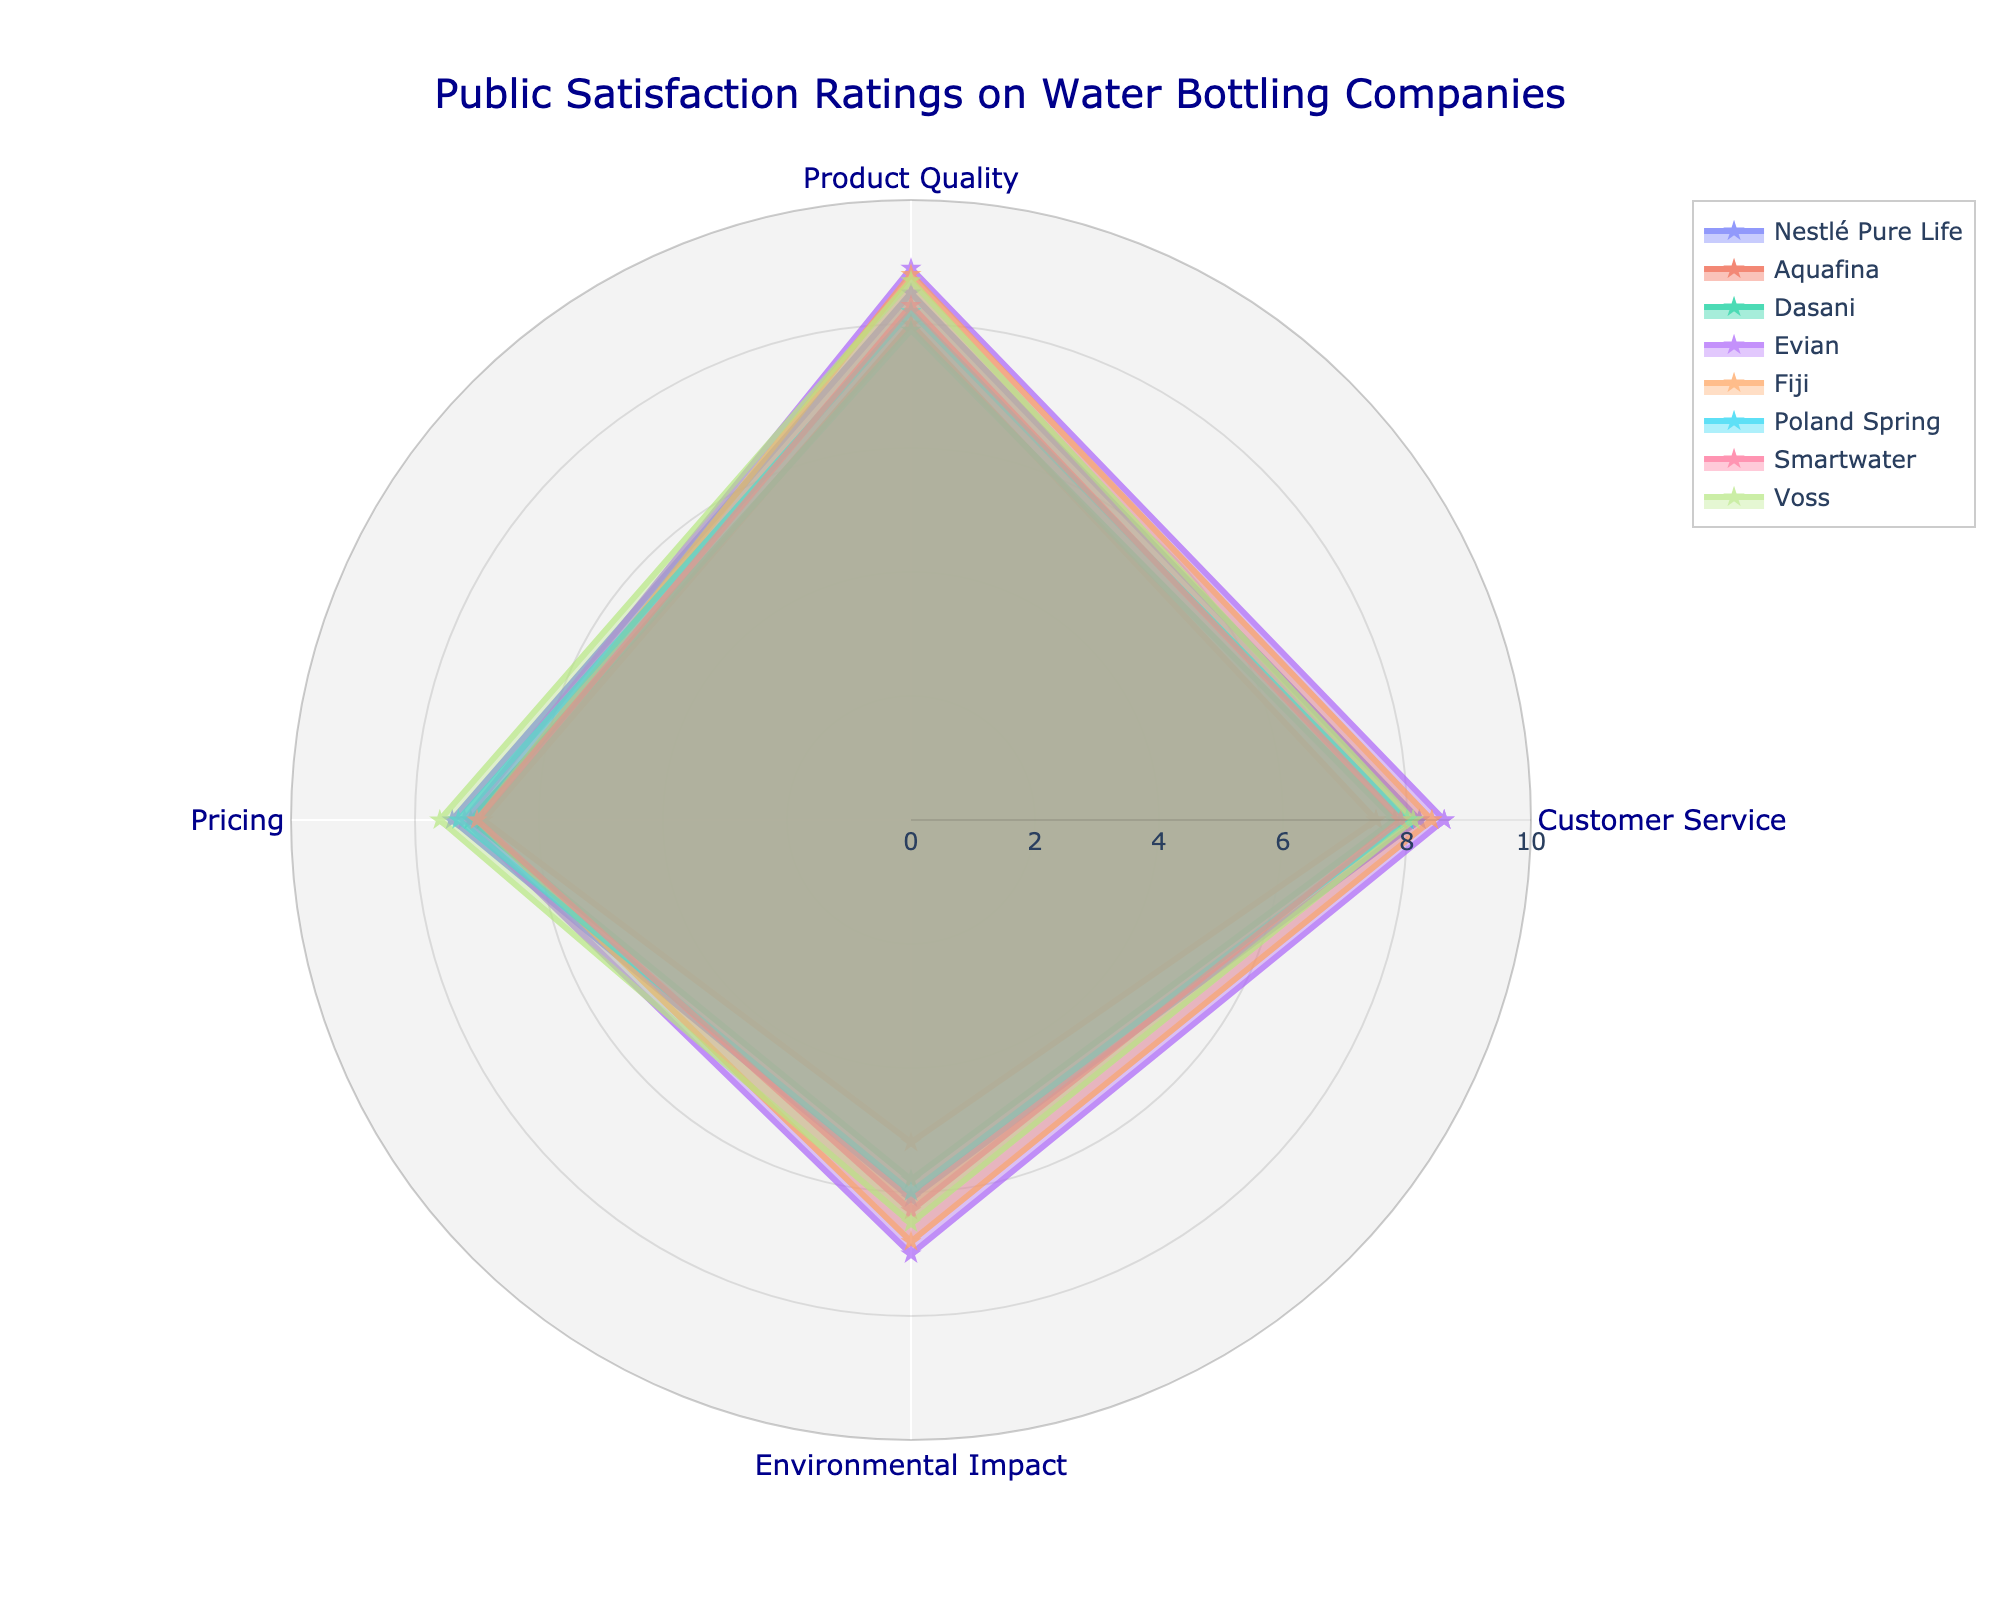How many categories are evaluated for each water company? The radar chart has four axes, each representing a different category. The categories are Customer Service, Product Quality, Pricing, and Environmental Impact. By counting these axes, we see that there are four categories.
Answer: Four Which company has the highest rating for Product Quality? Looking at the radar chart, the company with the highest point on the 'Product Quality' axis is Evian, which scores 8.9 in this category.
Answer: Evian Between Aquafina and Fiji, which company is rated higher in Environmental Impact? On the 'Environmental Impact' axis, Fiji is closer to the outer edge than Aquafina. Aquafina has a rating of 5.2, while Fiji is rated 6.8.
Answer: Fiji What is the average Product Quality rating across all companies? Sum the Product Quality ratings for all companies: (8.5 + 8.0 + 7.9 + 8.9 + 8.8 + 8.2 + 8.3 + 8.7). The total is 67.3. Divide by the number of companies, which is 8. Thus, the average is 67.3 / 8 = 8.41.
Answer: 8.41 Which company has the most balanced ratings across all categories? To identify the most balanced company, look for the shape that is closest to a complete polygon without significant peaks or troughs. Voss has a fairly balanced shape with moderately high but not extreme values in each category.
Answer: Voss What is the difference in Customer Service ratings between the highest and lowest-rated companies? The highest rating for Customer Service is 8.6 by Evian, while the lowest is 7.5 by Aquafina. The difference is 8.6 - 7.5 = 1.1.
Answer: 1.1 Which company has the lowest overall satisfaction in Pricing? The company closest to the center on the 'Pricing' axis is Aquafina, which scores 6.9 in this category.
Answer: Aquafina Do any two companies have the same rating in any category? By inspecting the radar chart, we see that Smartwater and Fiji both have the same rating of 7.0 in Pricing.
Answer: Yes, Smartwater and Fiji If you could only improve one category for Poland Spring to make its overall ratings better, which should it be? Poland Spring has its lowest rating in Environmental Impact at 6.0. Improving this category would impact its overall balance most significantly.
Answer: Environmental Impact 